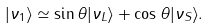<formula> <loc_0><loc_0><loc_500><loc_500>| \nu _ { 1 } \rangle \simeq \sin \theta | \nu _ { L } \rangle + \cos \theta | \nu _ { S } \rangle .</formula> 